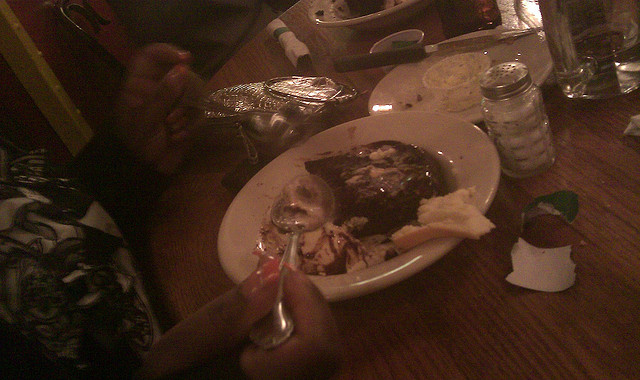<image>What is the source of protein in this meal? I am not sure about the source of protein in this meal. It could be meat, steak, beef or fish. What is the source of protein in this meal? I am not sure what the source of protein in this meal is. It can be either meat, steak, beef or fish. 